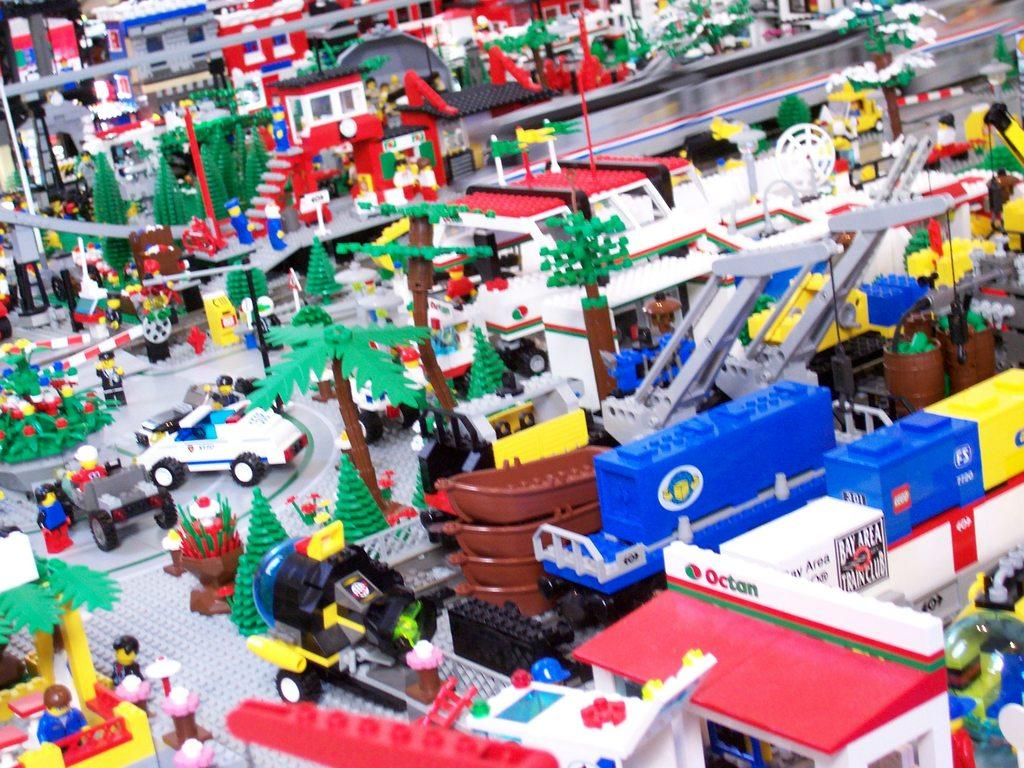What type of objects are in the image? There are toys in the image. What kind of toys can be seen in the image? The toys include vehicles and cars, as well as people. What can be seen in the background of the image? There are trees, a road, and buildings in the image. What type of art can be seen hanging on the walls in the image? There is no art visible on the walls in the image; it features toys and background elements. What mode of transport is available for the people in the image? The image does not show any mode of transport for the people; it only features toys and background elements. 